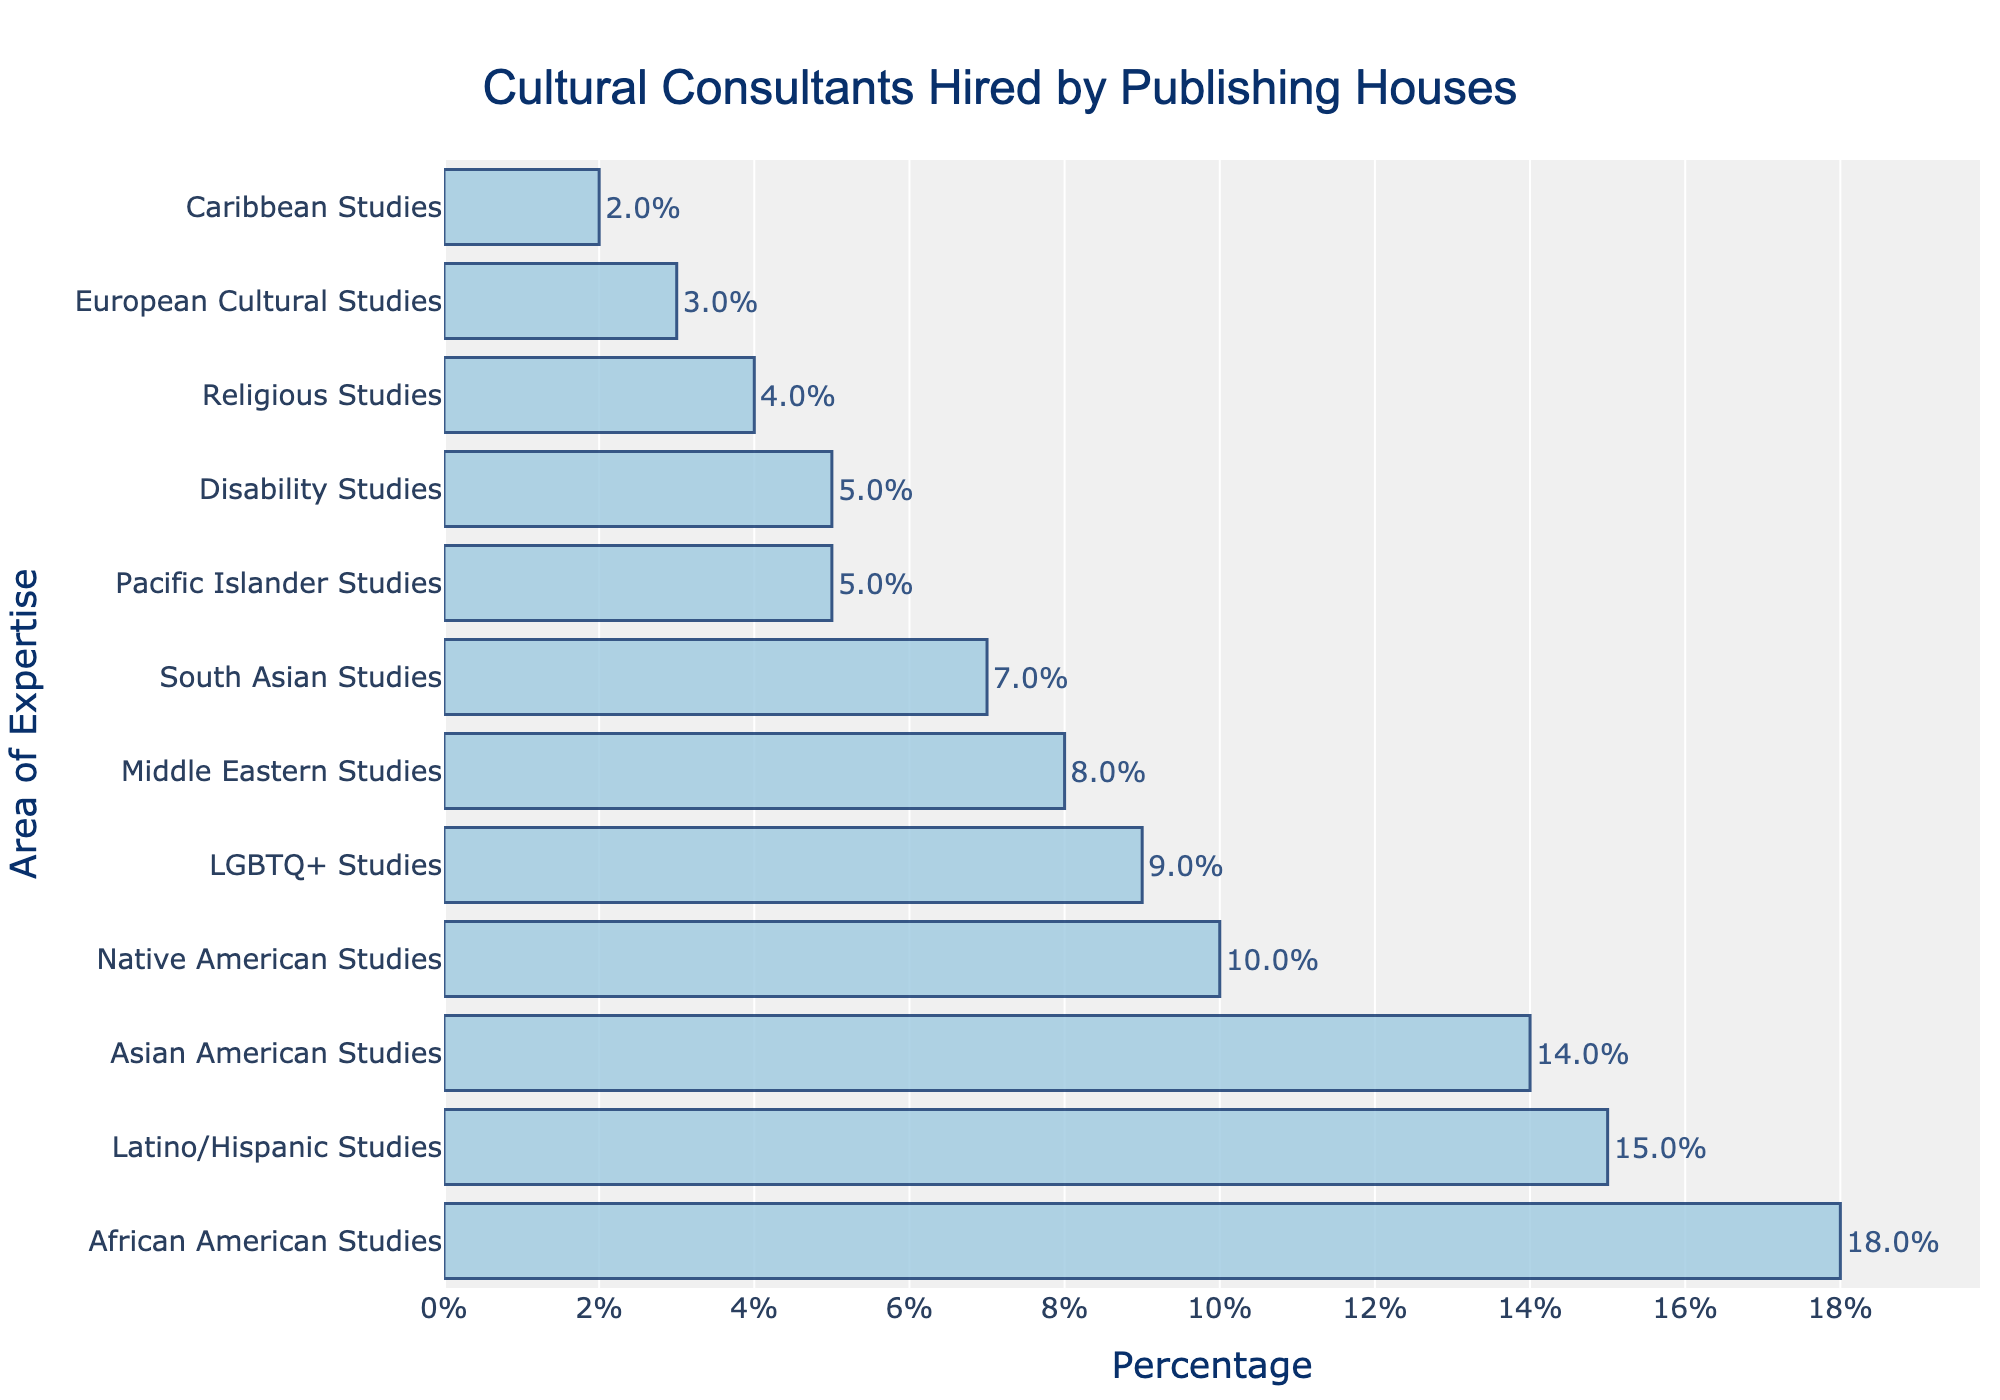What percentage of cultural consultants are specialized in African American Studies? The figure shows a bar chart with varying percentages for each area of expertise. Locate the bar labeled "African American Studies" and read the percentage value.
Answer: 18% Which area of expertise has the lowest percentage of cultural consultants hired? The figure shows a bar chart with varying percentages. Identify the shortest bar, which corresponds to the area with the lowest percentage, labeled "Caribbean Studies."
Answer: Caribbean Studies Compare the percentage of consultants hired for Asian American Studies and Latino/Hispanic Studies. Which area has a higher percentage and by how much? Locate the bars for "Asian American Studies" and "Latino/Hispanic Studies." Asian American Studies is at 14%, and Latino/Hispanic Studies is at 15%. Subtract the percentage of Asian American Studies from Latino/Hispanic Studies: 15% - 14% = 1%.
Answer: Latino/Hispanic Studies by 1% What is the combined percentage of cultural consultants hired for Pacific Islander Studies and Disability Studies? Locate the bars for "Pacific Islander Studies" and "Disability Studies." Their percentages are 5% and 5%, respectively. Add these percentages: 5% + 5% = 10%.
Answer: 10% Which areas of expertise have the same percentage of cultural consultants hired? Identify bars with the same length/percentage value. "Pacific Islander Studies" and "Disability Studies" both have a percentage of 5%.
Answer: Pacific Islander Studies and Disability Studies What is the total percentage of consultants hired for Native American Studies, LGBTQ+ Studies, and Middle Eastern Studies? Locate the bars labeled "Native American Studies," "LGBTQ+ Studies," and "Middle Eastern Studies." Their percentages are 10%, 9%, and 8%, respectively. Add these values: 10% + 9% + 8% = 27%.
Answer: 27% Which group has a higher percentage: South Asian Studies or Religious Studies? By how much? Locate the bars for "South Asian Studies" and "Religious Studies." South Asian Studies stands at 7%, and Religious Studies at 4%. Subtract the smaller percentage from the larger one: 7% - 4% = 3%.
Answer: South Asian Studies by 3% Rank the top three areas of expertise in terms of the percentage of cultural consultants hired. Identify the top three longest bars in the chart. The top three areas are "African American Studies" (18%), "Latino/Hispanic Studies" (15%), and "Asian American Studies" (14%).
Answer: African American Studies, Latino/Hispanic Studies, Asian American Studies Is the percentage of consultants hired for European Cultural Studies greater than that of Caribbean Studies? Compare the bars for "European Cultural Studies" (3%) and "Caribbean Studies" (2%).
Answer: Yes What is the difference in percentage between the most and least hired cultural consultants? Identify the longest bar ("African American Studies" at 18%) and the shortest bar ("Caribbean Studies" at 2%). Subtract the smallest percentage from the largest: 18% - 2% = 16%.
Answer: 16% 